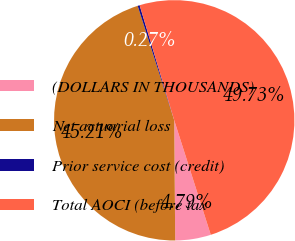Convert chart to OTSL. <chart><loc_0><loc_0><loc_500><loc_500><pie_chart><fcel>(DOLLARS IN THOUSANDS)<fcel>Net actuarial loss<fcel>Prior service cost (credit)<fcel>Total AOCI (before tax<nl><fcel>4.79%<fcel>45.21%<fcel>0.27%<fcel>49.73%<nl></chart> 